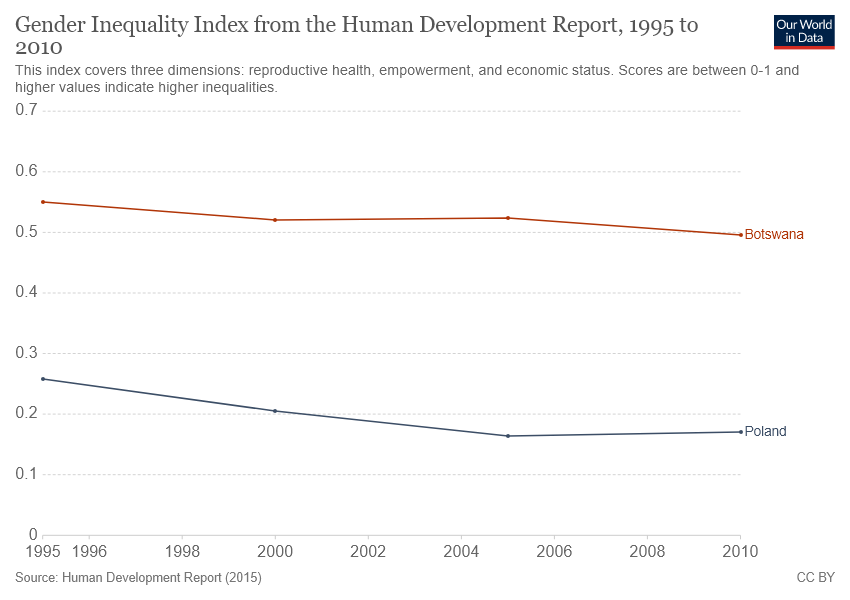Highlight a few significant elements in this photo. In 2010, the approximate ratio between Botswana and Poland was 0.220833333... 